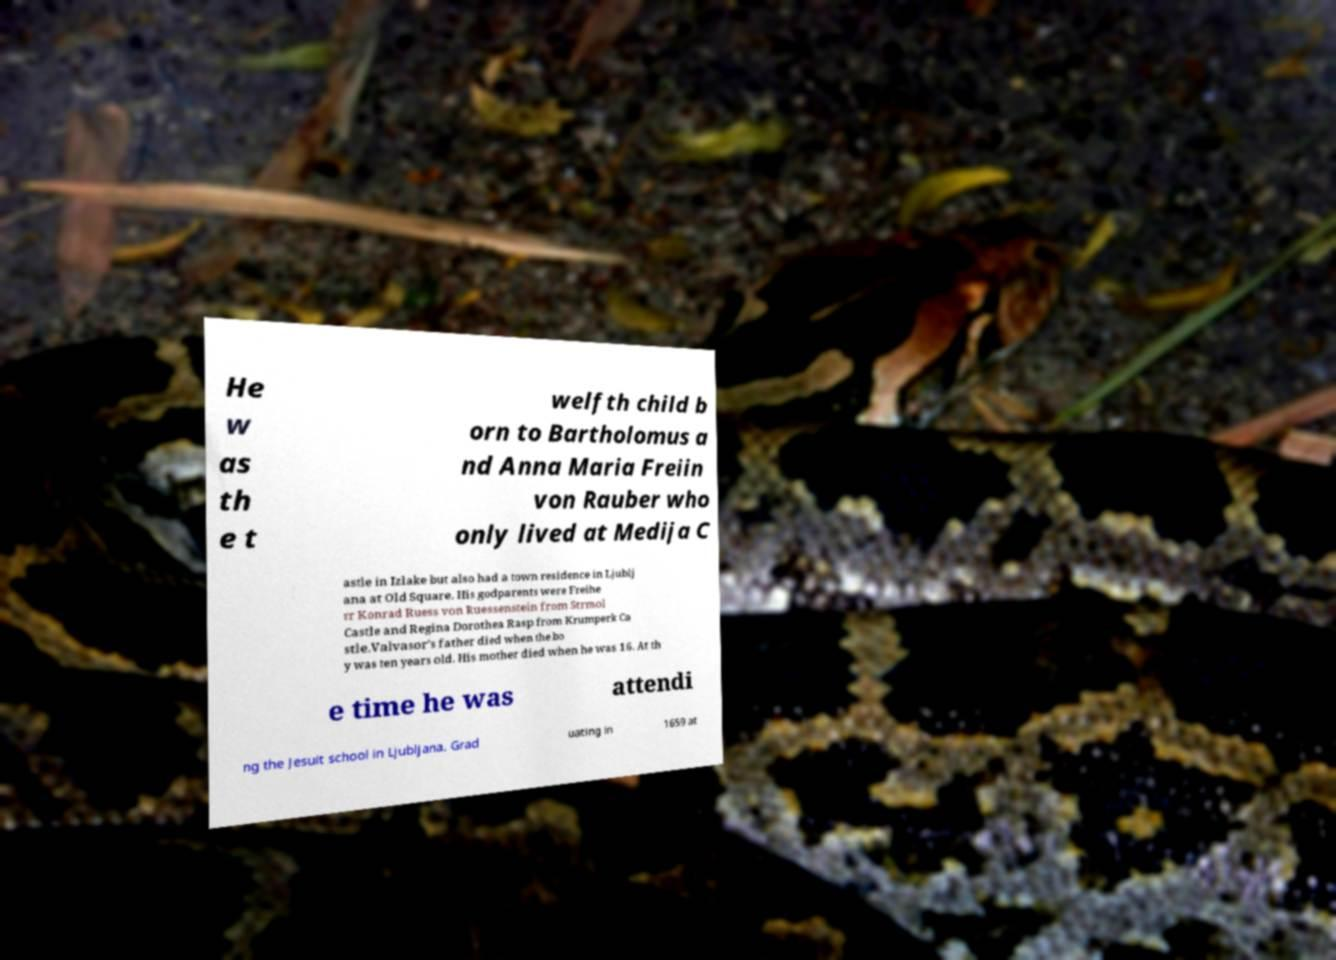What messages or text are displayed in this image? I need them in a readable, typed format. He w as th e t welfth child b orn to Bartholomus a nd Anna Maria Freiin von Rauber who only lived at Medija C astle in Izlake but also had a town residence in Ljublj ana at Old Square. His godparents were Freihe rr Konrad Ruess von Ruessenstein from Strmol Castle and Regina Dorothea Rasp from Krumperk Ca stle.Valvasor's father died when the bo y was ten years old. His mother died when he was 16. At th e time he was attendi ng the Jesuit school in Ljubljana. Grad uating in 1659 at 